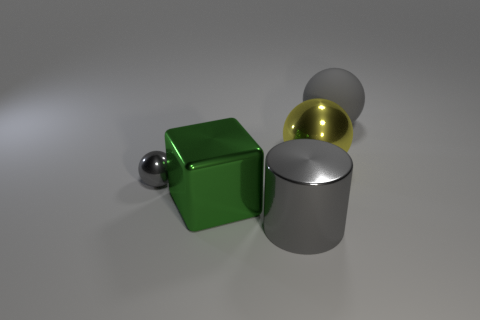The large object that is both to the right of the shiny cylinder and to the left of the gray rubber ball is what color?
Offer a very short reply. Yellow. Is there a large cube that has the same color as the tiny object?
Offer a very short reply. No. There is a big metal thing on the left side of the metal cylinder; what color is it?
Your response must be concise. Green. There is a large thing in front of the big metal cube; is there a gray metal ball to the right of it?
Provide a short and direct response. No. Do the big metal cube and the shiny sphere that is on the left side of the big shiny cube have the same color?
Keep it short and to the point. No. Is there a small gray ball that has the same material as the tiny object?
Offer a terse response. No. How many shiny blocks are there?
Offer a terse response. 1. What is the material of the gray thing on the left side of the big thing in front of the metallic block?
Keep it short and to the point. Metal. There is a big cylinder that is the same material as the green cube; what is its color?
Keep it short and to the point. Gray. What is the shape of the other big thing that is the same color as the big matte thing?
Ensure brevity in your answer.  Cylinder. 